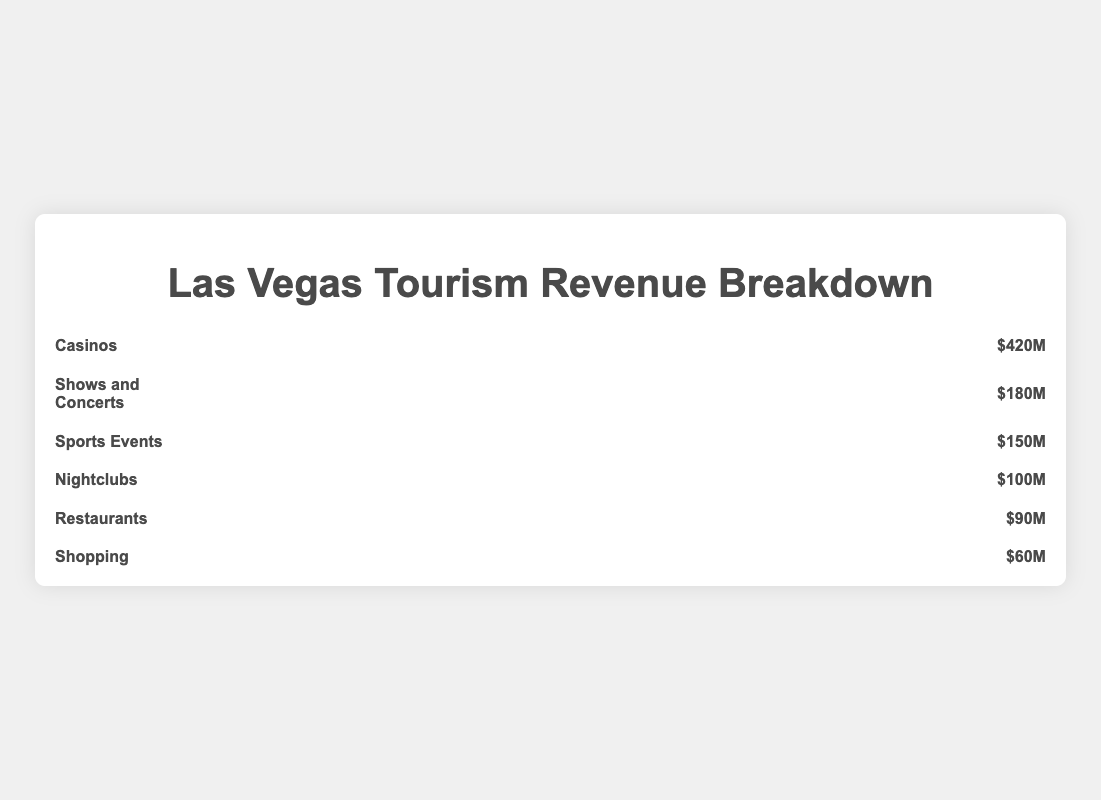What sector generates the highest amount of revenue? The sector with the highest amount of revenue can be identified by looking for the sector with the most icons and the highest dollar value displayed. Casinos have the highest revenue with seven icons and a revenue of $420M.
Answer: Casinos What is the total revenue generated by Nightclubs and Restaurants combined? To find the total revenue, add the revenue from Nightclubs ($100M) and Restaurants ($90M). 100M + 90M = 190M.
Answer: $190M Which sector contributes the least to the revenue? The sector with the fewest icons and lowest dollar value will have the least revenue. Shopping has only one icon and a revenue of $60M, making it the least contributor.
Answer: Shopping How much more revenue do Casinos generate compared to Sports Events? Subtract the revenue from Sports Events ($150M) from the revenue of Casinos ($420M). 420M - 150M = 270M.
Answer: $270M What is the average revenue of Shows and Concerts, Sports Events, and Nightclubs? Sum the revenues of Shows and Concerts ($180M), Sports Events ($150M), and Nightclubs ($100M), then divide by the number of sectors. (180M + 150M + 100M) / 3 = 430M / 3 ≈ 143.33M.
Answer: $143.33M What percentage of the total tourism revenue is generated by Shows and Concerts? First, find the total revenue by summing up all sector revenues: 420M + 180M + 150M + 100M + 90M + 60M = 1000M. Then, divide Shows and Concerts revenue by the total revenue and multiply by 100: (180M / 1000M) * 100 ≈ 18%.
Answer: 18% Which sectors generate over $100M in revenue? Sectors with revenues over $100M are those with more than two icons and a dollar value above $100M. Casinos ($420M), Shows and Concerts ($180M), and Sports Events ($150M) generate more than $100M.
Answer: Casinos, Shows and Concerts, Sports Events If we combine the revenue of Casinos and Shopping, how much more is it compared to the total revenue of Restaurants and Nightclubs? First, find the combined revenue of Casinos and Shopping: 420M + 60M = 480M. Then, find the combined revenue of Restaurants and Nightclubs: 90M + 100M = 190M. Finally, subtract the second sum from the first: 480M - 190M = 290M.
Answer: $290M What is the median revenue among all sectors? List the sector revenues in ascending order and find the middle value. The ordered revenues are: 60M, 90M, 100M, 150M, 180M, 420M. Since there are six values, the median is the average of the third and fourth values, which are 100M and 150M. (100M + 150M) / 2 = 125M.
Answer: $125M 